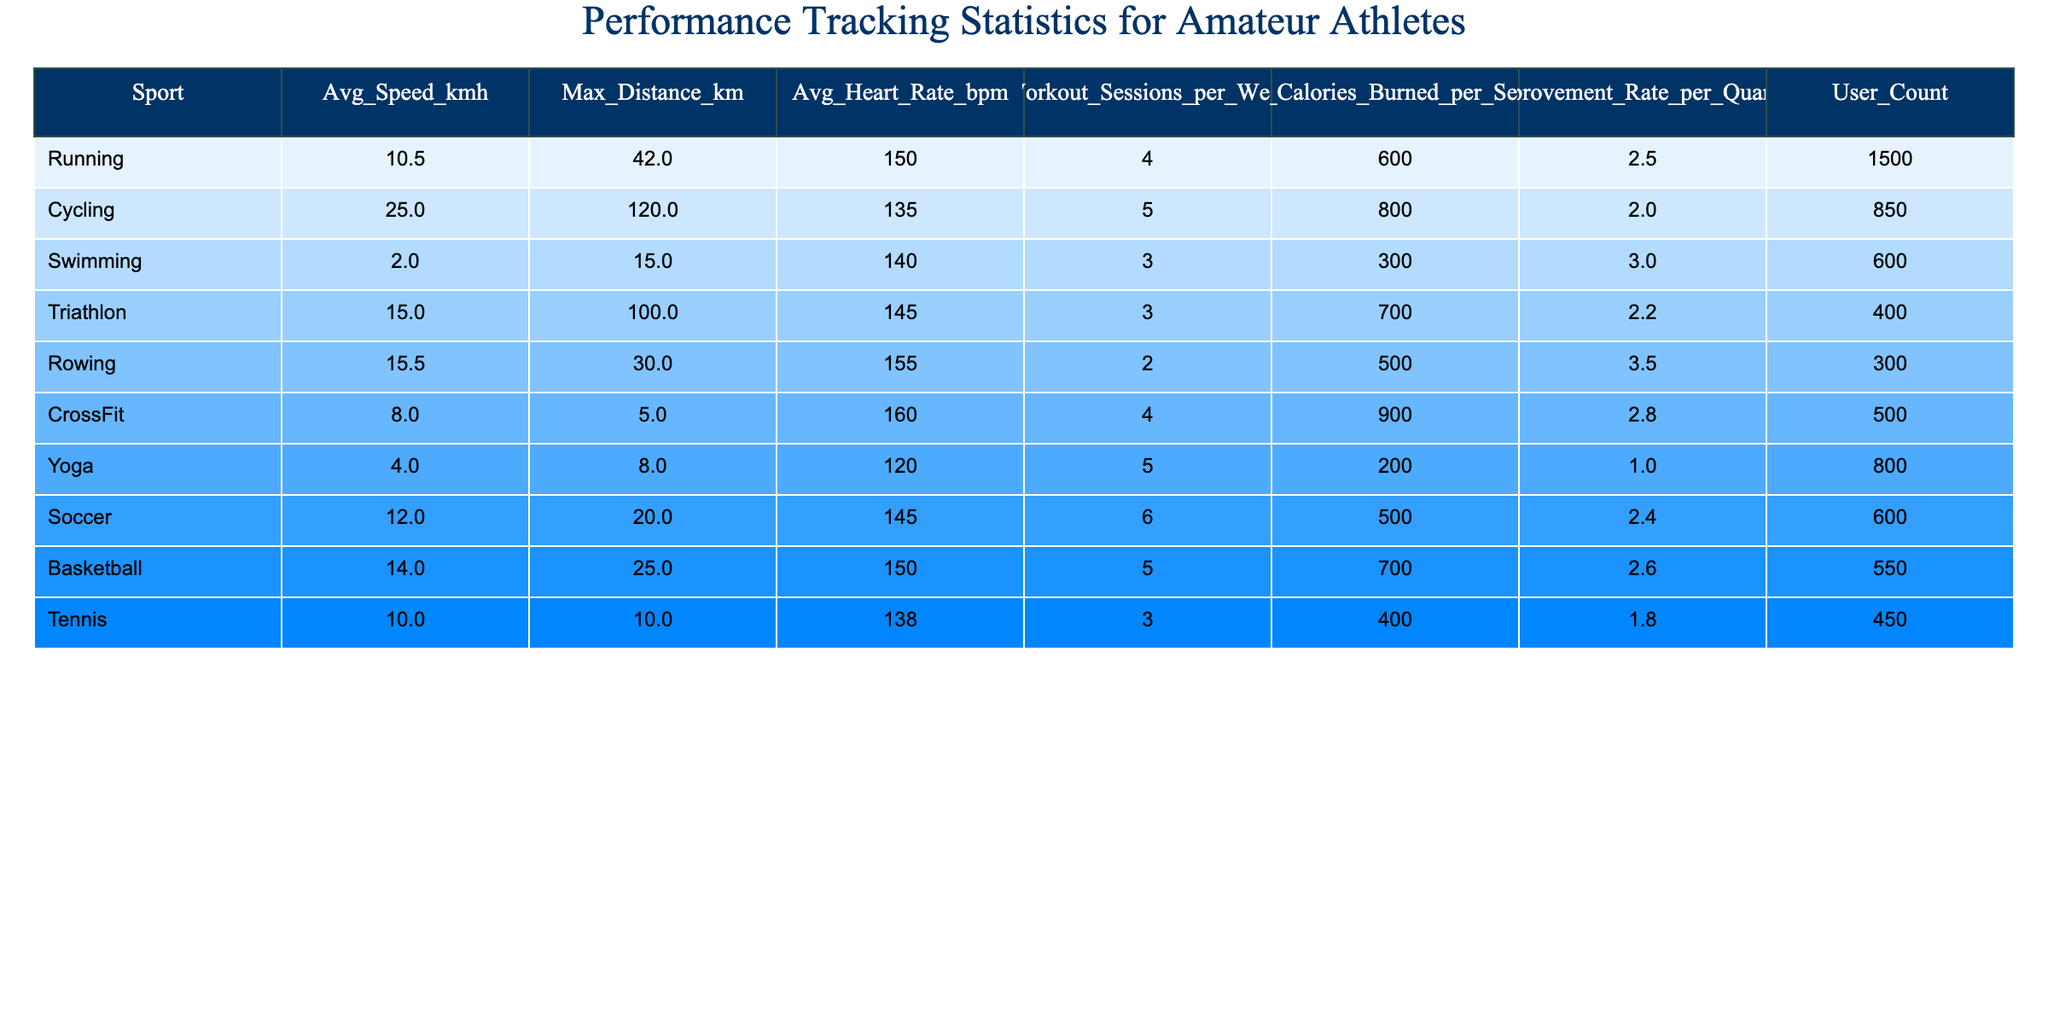What's the average speed of cyclists? The table shows the average speed for cycling as 25.0 km/h directly listed under the "Avg_Speed_kmh" column for the sport "Cycling."
Answer: 25.0 km/h Which sport has the highest max distance covered? The "Max_Distance_km" column indicates that cycling has the highest max distance at 120.0 km.
Answer: Cycling What is the average heart rate for soccer players? The table provides the average heart rate for soccer under the "Avg_Heart_Rate_bpm" column, which is 145 bpm.
Answer: 145 bpm How many workout sessions per week do rowing athletes average? The "Workout_Sessions_per_Week" column shows that rowing athletes average 2 sessions per week.
Answer: 2 sessions Which sport has the highest improvement rate per quartile? The highest value in the "Improvement_Rate_per_Quartile" column is 3.5, corresponding to rowing.
Answer: Rowing What is the average number of calories burned per session in CrossFit? Looking at the "Avg_Calories_Burned_per_Session" column, CrossFit athletes burn an average of 900 calories per session.
Answer: 900 calories Calculate the total user count across all sports. Adding the "User_Count" values gives 1500 + 850 + 600 + 400 + 300 + 500 + 800 + 600 + 550 + 450 = 5250.
Answer: 5250 Which sport has the lowest average speed? The "Avg_Speed_kmh" column shows that swimming has the lowest average speed at 2.0 km/h.
Answer: Swimming Is the average calories burned per session in Yoga higher than in Swimming? The average calories burned for Yoga is 200, and for Swimming, it’s 300, so 200 < 300, indicating that Yoga has a lower average.
Answer: No Which sport has the most workout sessions per week and what is that number? Soccer has the most workout sessions with a value of 6 in the "Workout_Sessions_per_Week" column.
Answer: 6 sessions If an athlete involved in CrossFit worked out for 4 weeks, how many calories would they expect to burn in total? They burn 900 calories per session and average 4 sessions per week, totaling 900 * 4 * 4 = 14400 calories over 4 weeks.
Answer: 14400 calories 